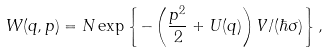Convert formula to latex. <formula><loc_0><loc_0><loc_500><loc_500>W ( q , p ) = N \exp \left \{ - \left ( \frac { p ^ { 2 } } 2 + U ( q ) \right ) V / ( \hbar { \sigma } ) \right \} ,</formula> 